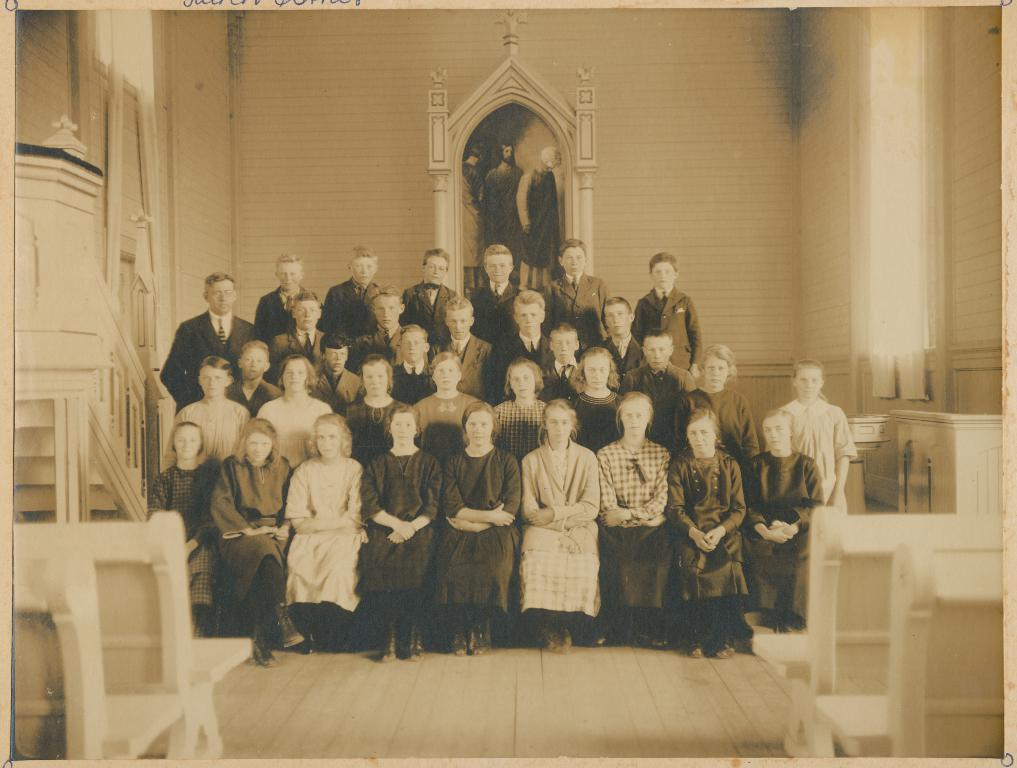How many people are present in the room in the image? There are many people inside the room in the image. What can be seen on the wall in the room? There is a painting on the wall in the room. What type of seating is available in the room? There are benches on both sides of the room. What feature is present near the windows in the room? There are curtains near the windows in the room. What is the queen's opinion on the painting in the image? There is no queen present in the image, and therefore her opinion on the painting cannot be determined. 